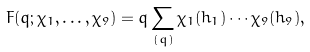Convert formula to latex. <formula><loc_0><loc_0><loc_500><loc_500>F ( q ; \chi _ { 1 } , \dots , \chi _ { 9 } ) = q \sum _ { ( q ) } \chi _ { 1 } ( h _ { 1 } ) \cdots \chi _ { 9 } ( h _ { 9 } ) ,</formula> 